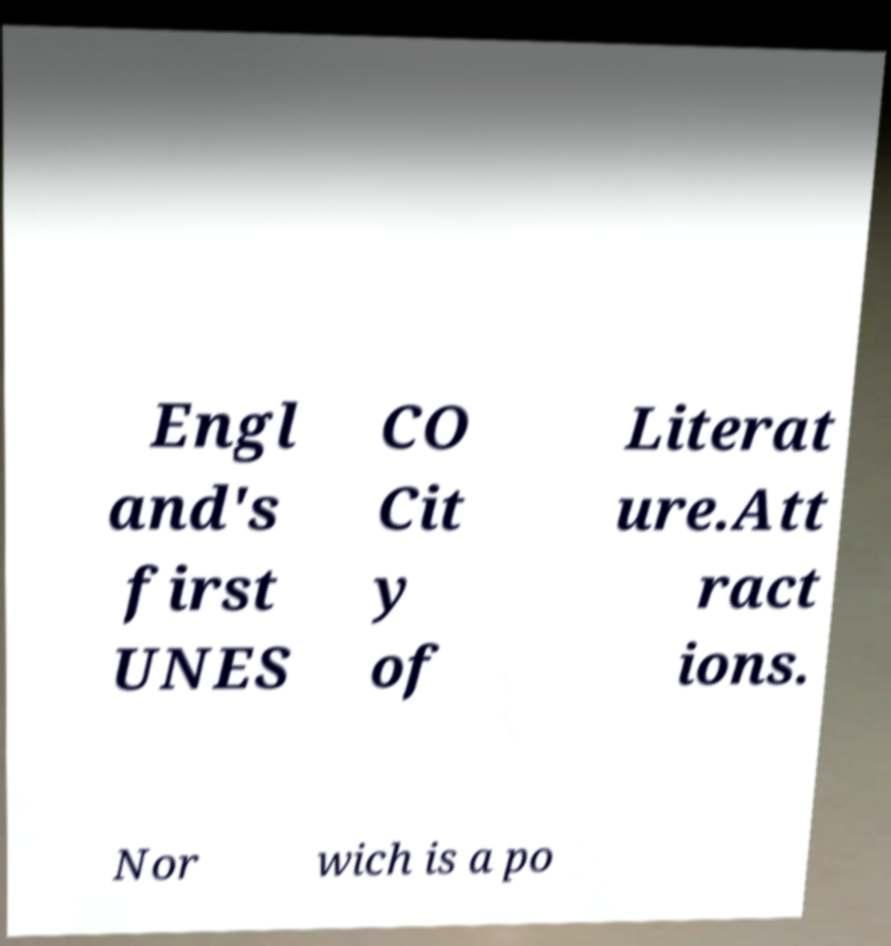Could you assist in decoding the text presented in this image and type it out clearly? Engl and's first UNES CO Cit y of Literat ure.Att ract ions. Nor wich is a po 